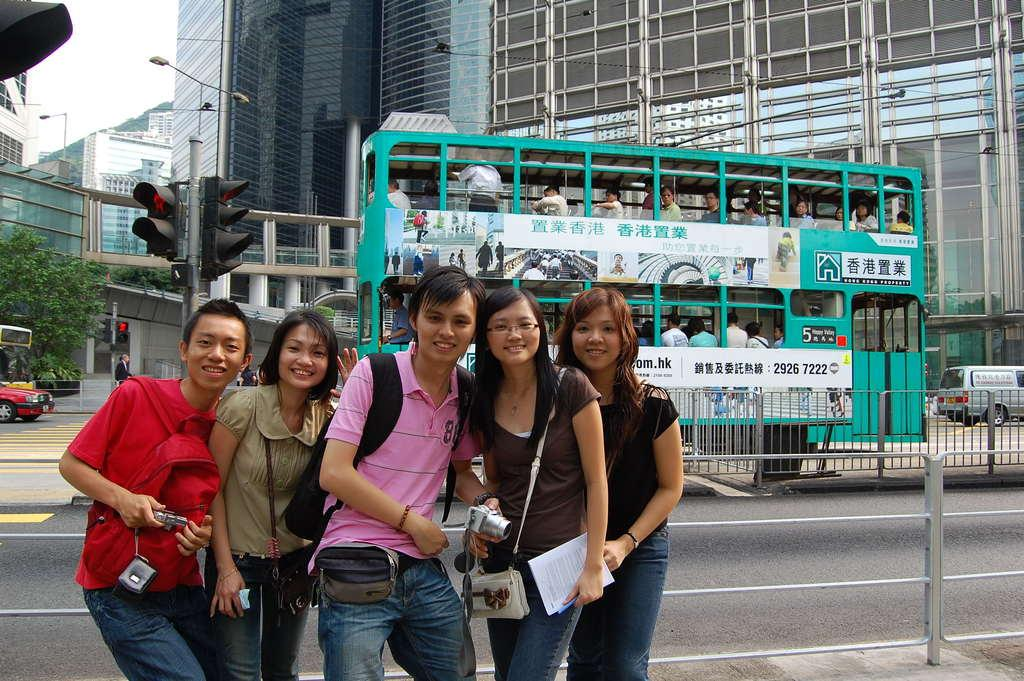Provide a one-sentence caption for the provided image. Turqouise bus with the numbers "29267222" right behind a group of people taking a picture. 